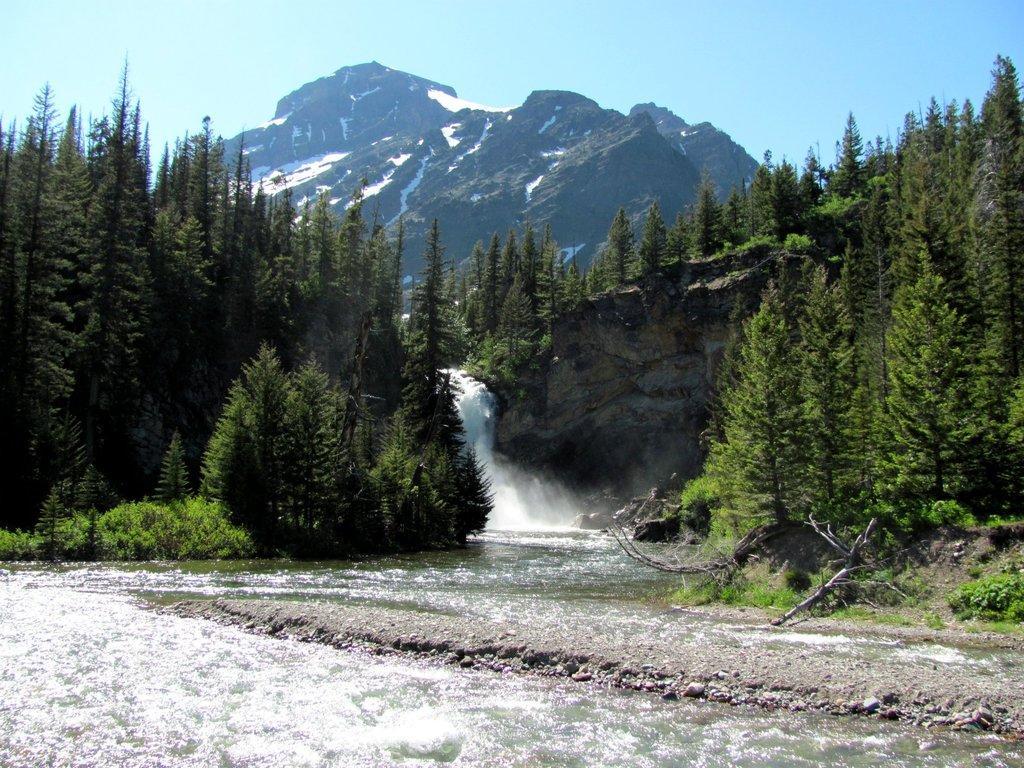Describe this image in one or two sentences. This picture is clicked outside the city. In the foreground we can see a water body and some plants. In the center there is a waterfall and we can see the trees and some hills. In the background there is a sky. 